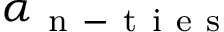<formula> <loc_0><loc_0><loc_500><loc_500>\alpha _ { n - t i e s }</formula> 